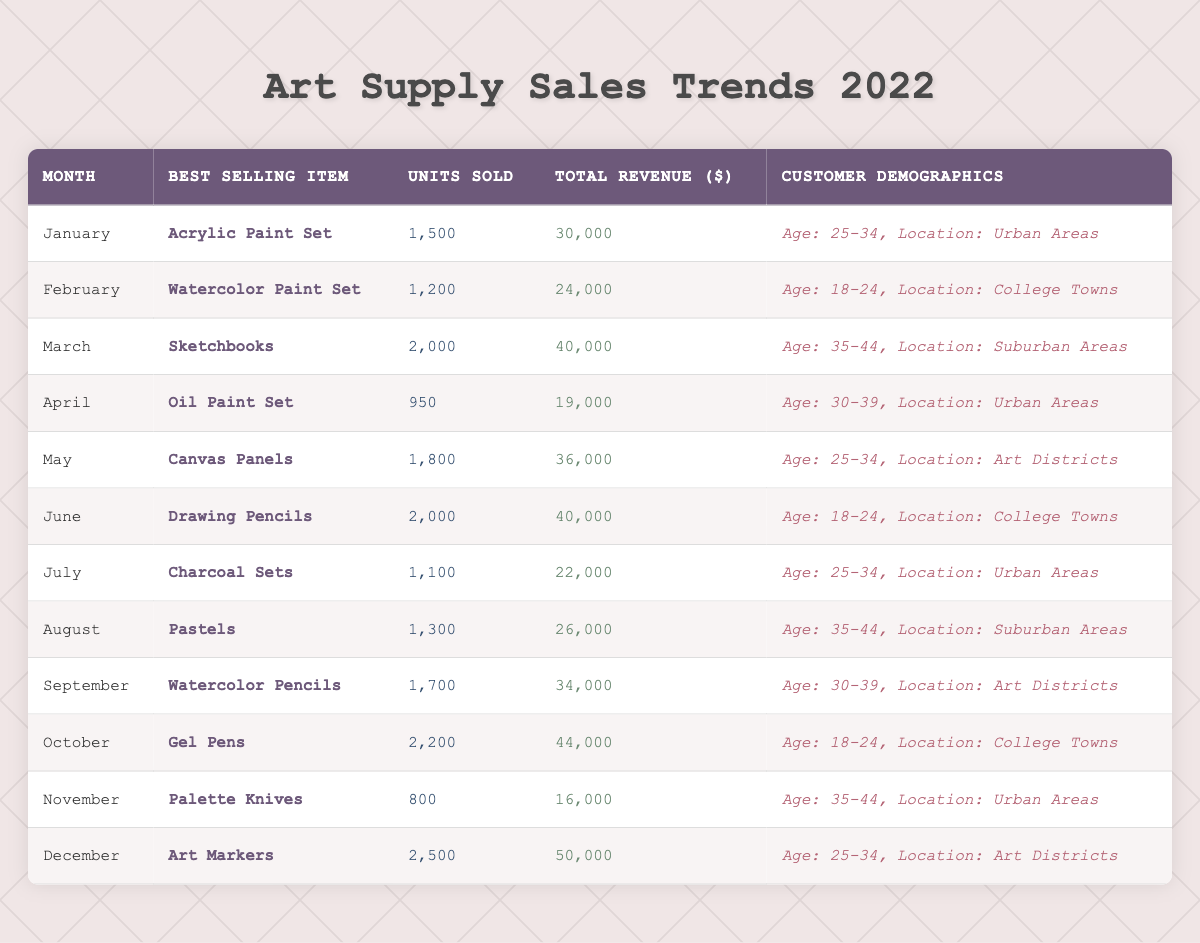What was the best-selling item in December? The table lists "Art Markers" as the best-selling item for December.
Answer: Art Markers How many units of Sketchbooks were sold in March? The table specifies that 2,000 units of Sketchbooks were sold in March.
Answer: 2,000 What was the total revenue for the best-selling item in July? For July, the best-selling item was "Charcoal Sets," with a total revenue of $22,000.
Answer: $22,000 Which month had the highest total revenue and what was that amount? December had the highest total revenue at $50,000.
Answer: $50,000 In which location were the most units of Drawing Pencils sold? According to the table, Drawing Pencils were most sold in "College Towns."
Answer: College Towns How many more units were sold in December compared to April? In December, 2,500 units were sold and in April, 950 units were sold. Subtracting gives 2,500 - 950 = 1,550 more units sold in December.
Answer: 1,550 What percentage of units sold in January does February's units represent? January had 1,500 units sold, while February had 1,200 units. To find the percentage: (1,200 / 1,500) * 100 = 80%.
Answer: 80% Is it true that the best-selling item in any month was an Oil Paint Set? Looking at the table, Oil Paint Set was a best-seller only in April, therefore the statement is true.
Answer: True Which age group purchased the most items on average throughout the year? To find the average per age group, I'll tally sales across months for each respective age group, then average them. The highest average is from the 18-24 age group.
Answer: 18-24 age group How many total units were sold in the first half of the year? The units sold from January to June are: 1,500 + 1,200 + 2,000 + 950 + 1,800 + 2,000 = 9,450 units in total.
Answer: 9,450 